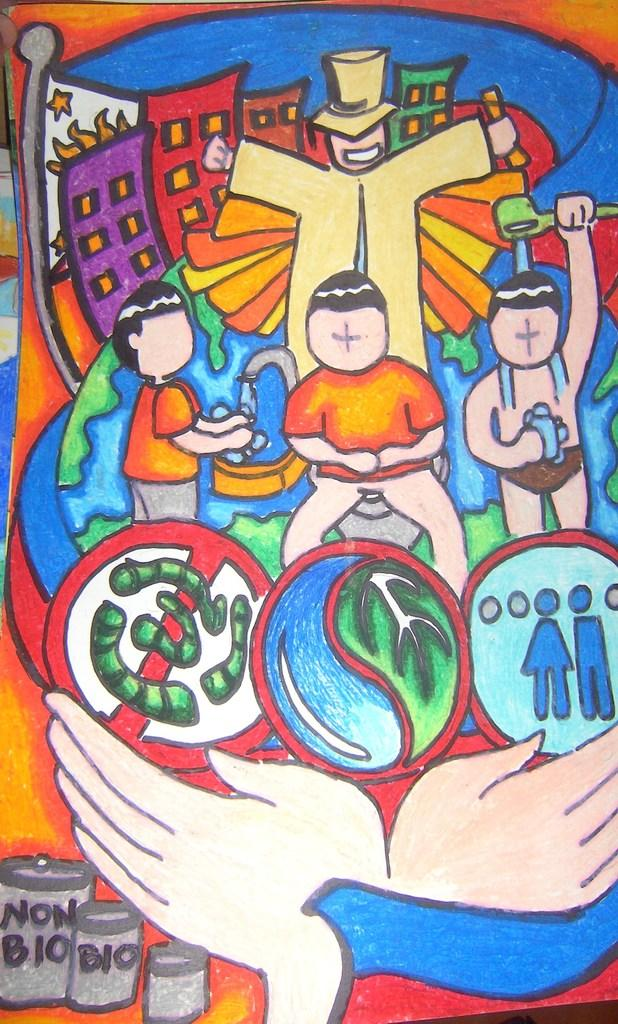What is the main subject in the image? There is a painting in the image. How loud is the desire expressed in the painting? There is no mention of a desire or any sound level in the image, as it only features a painting. 